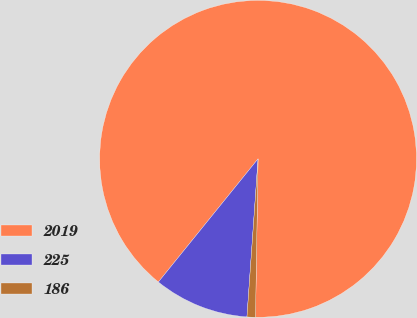Convert chart to OTSL. <chart><loc_0><loc_0><loc_500><loc_500><pie_chart><fcel>2019<fcel>225<fcel>186<nl><fcel>89.43%<fcel>9.71%<fcel>0.86%<nl></chart> 